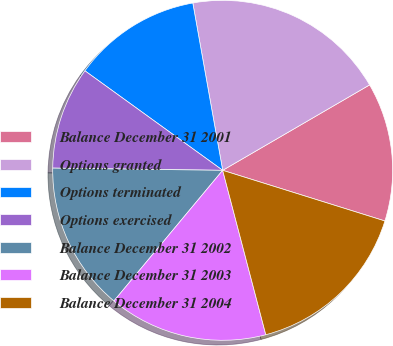Convert chart. <chart><loc_0><loc_0><loc_500><loc_500><pie_chart><fcel>Balance December 31 2001<fcel>Options granted<fcel>Options terminated<fcel>Options exercised<fcel>Balance December 31 2002<fcel>Balance December 31 2003<fcel>Balance December 31 2004<nl><fcel>13.2%<fcel>19.43%<fcel>12.23%<fcel>9.75%<fcel>14.16%<fcel>15.13%<fcel>16.1%<nl></chart> 